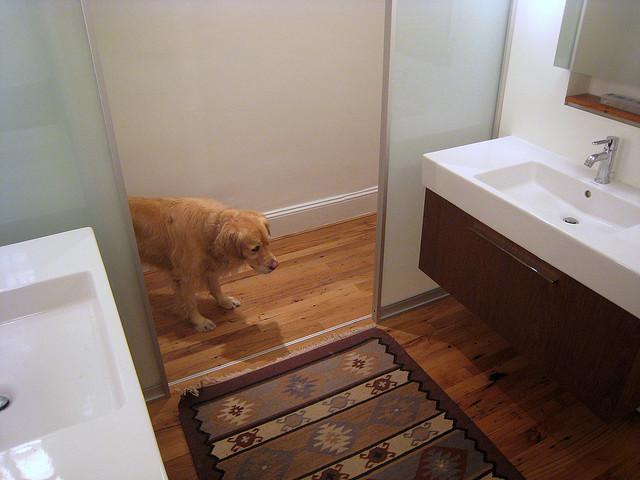What color is the dog standing inside of the doorway to the bathroom?
Answer the question by selecting the correct answer among the 4 following choices and explain your choice with a short sentence. The answer should be formatted with the following format: `Answer: choice
Rationale: rationale.`
Options: Gray, chocolate, golden, black. Answer: golden.
Rationale: The dog is a golden retriever. 